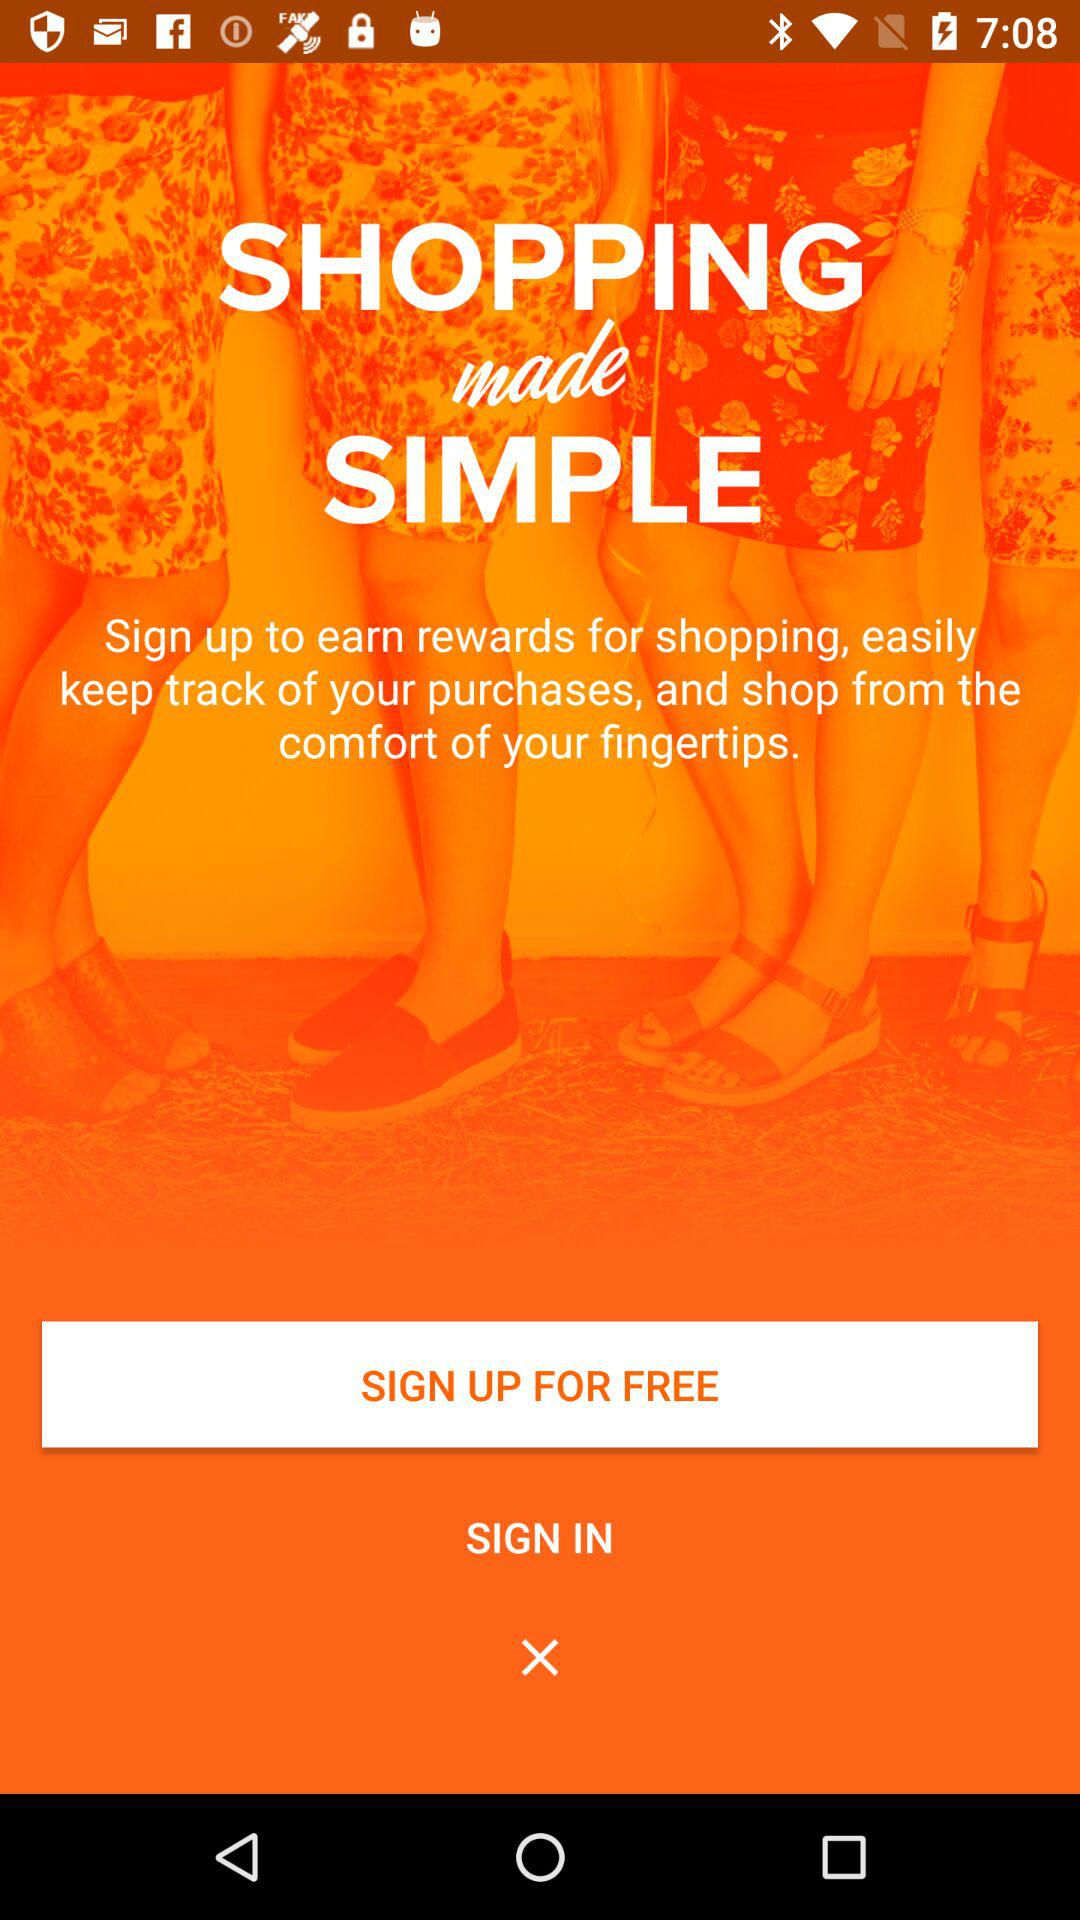What is the application name?
When the provided information is insufficient, respond with <no answer>. <no answer> 